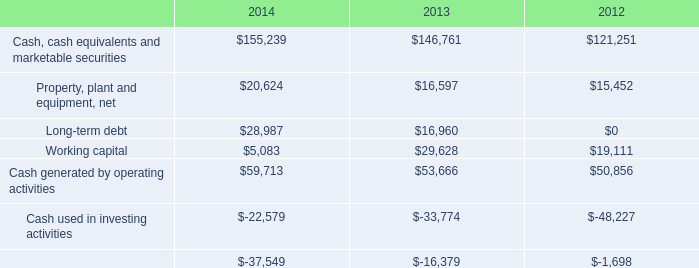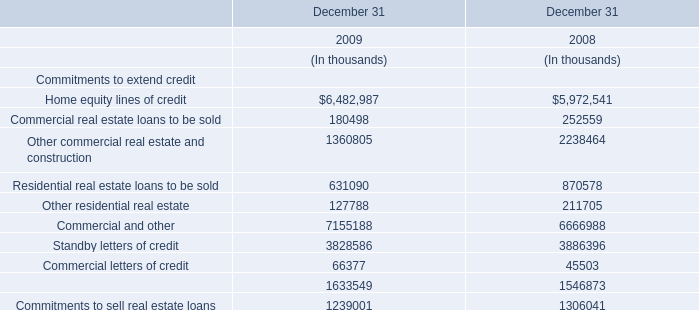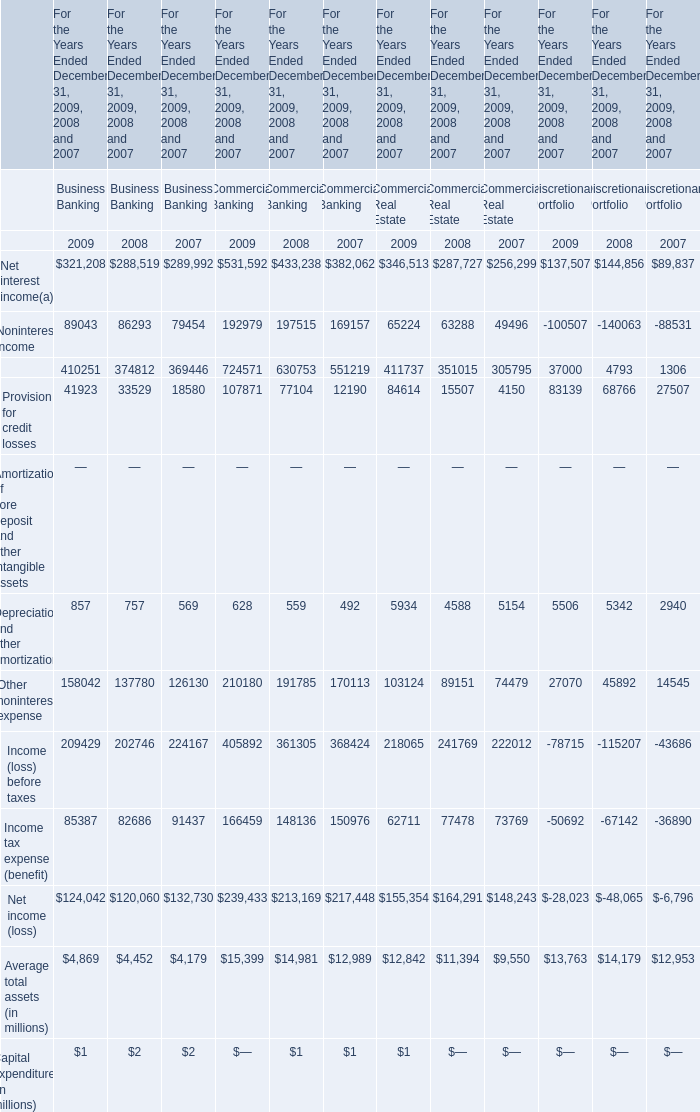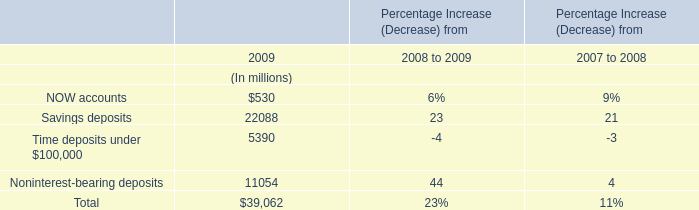What's the average of the Home equity lines of credit in 2009 and 2008 where NOW accounts is positive? 
Computations: ((6482987 + 5972541) / 2)
Answer: 6227764.0. 